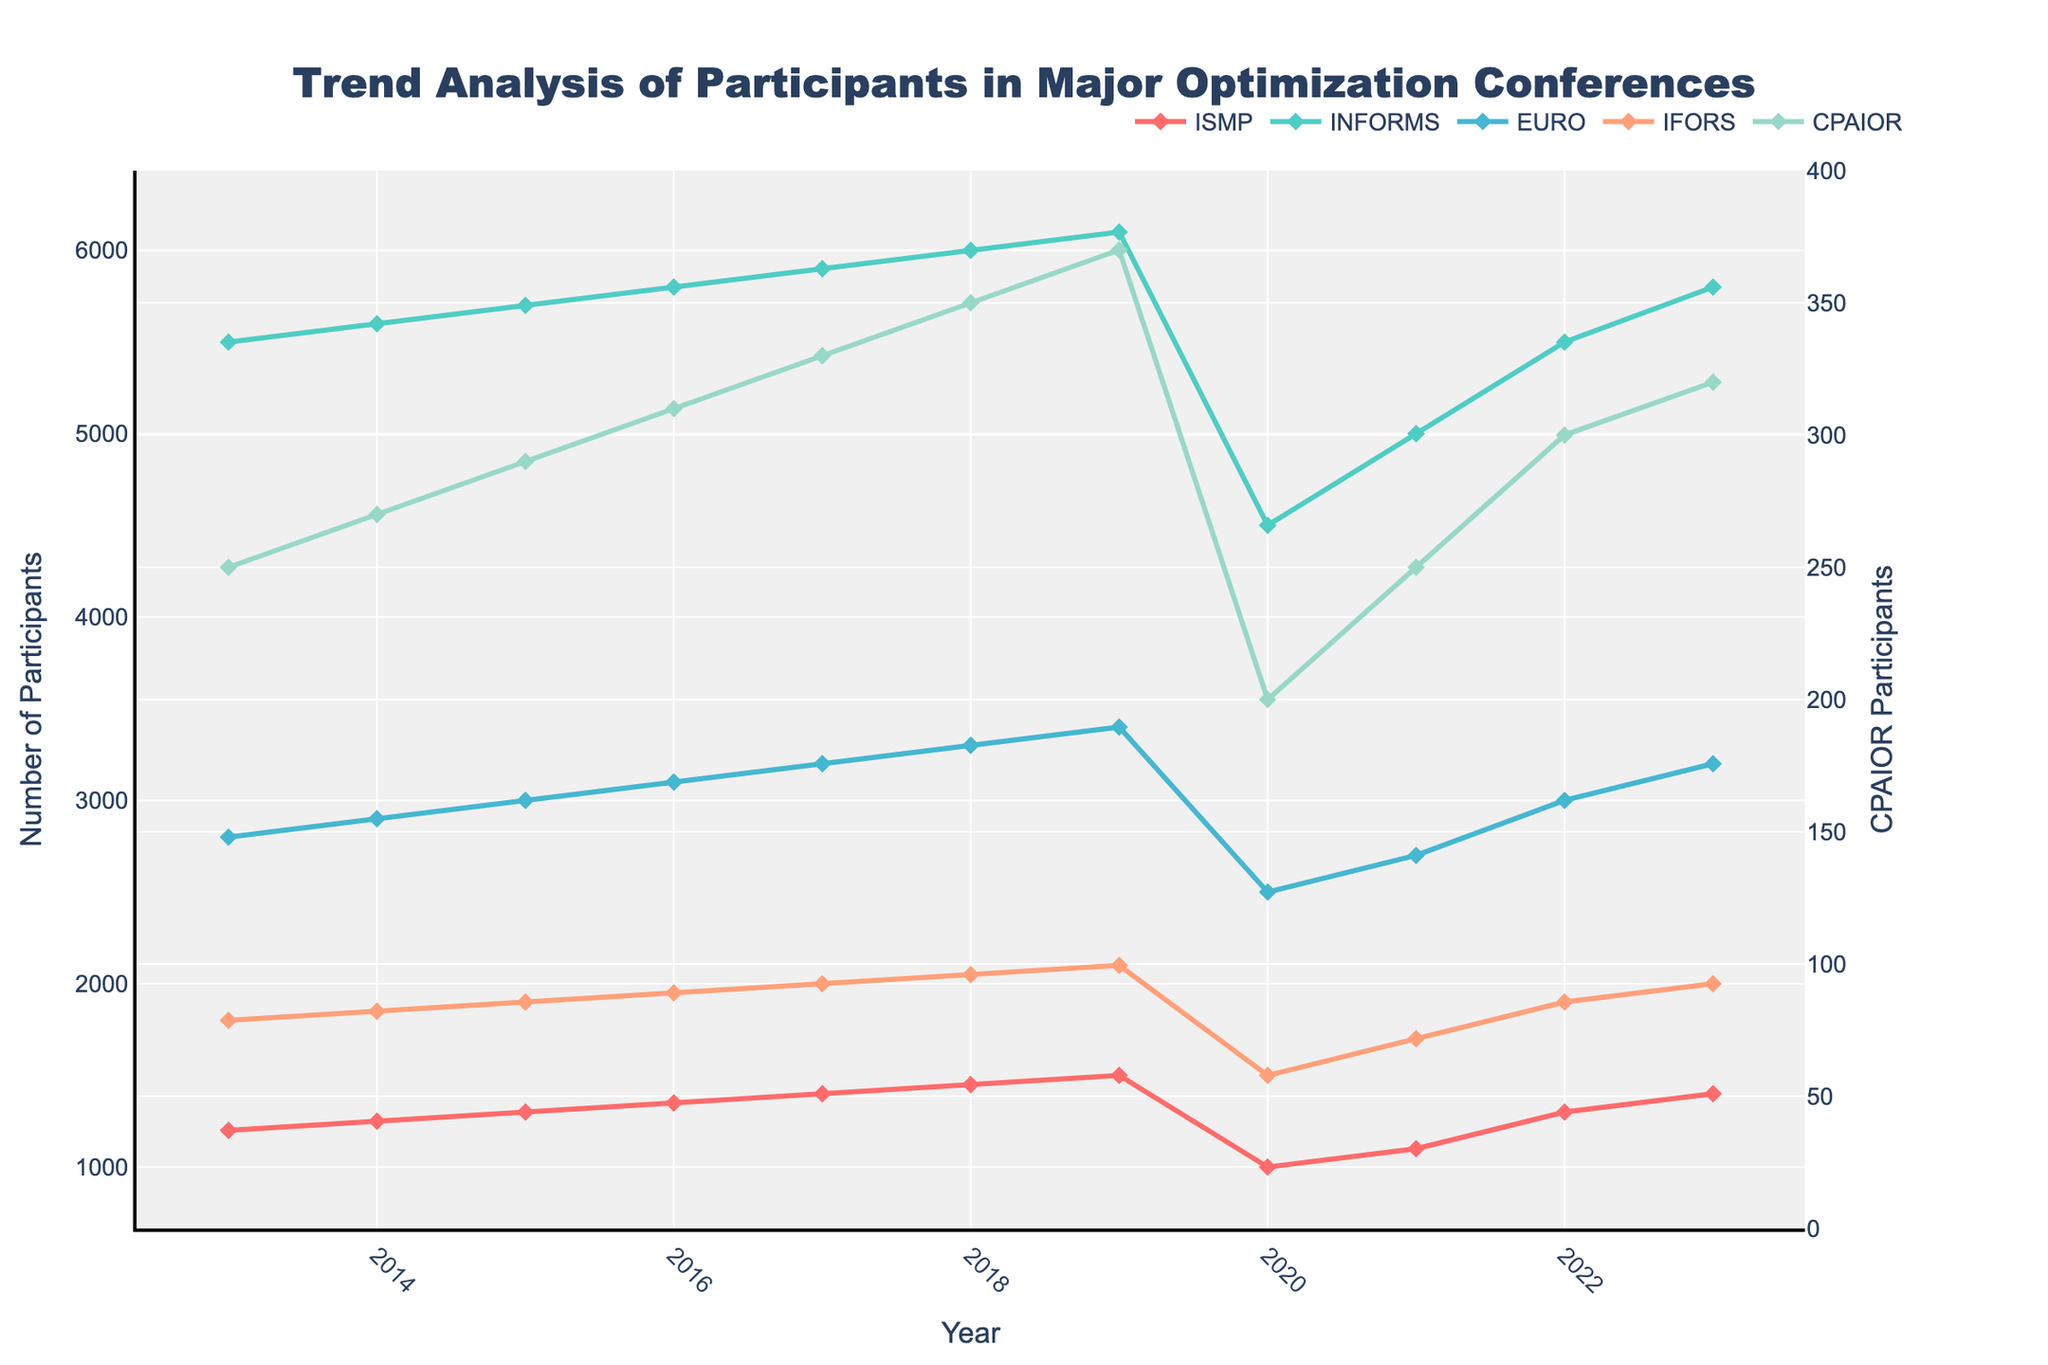What is the trend of participants in the ISMP conference over the years? The number of participants at the ISMP conference has generally increased from 1200 in 2013 to 1500 in 2019. There was a significant drop to 1000 in 2020, but the number showed recovery in subsequent years, reaching 1400 by 2023.
Answer: Increasing, then drop in 2020, recovery afterward What year did the IFORS conference see a decline in participants? In 2020, the number of participants in the IFORS conference dropped from 2100 in 2019 to 1500 in 2020.
Answer: 2020 Compare the growth in participants between the INFORMS and EURO conferences from 2013 to 2023. The INFORMS conference grew from 5500 participants in 2013 to 5800 in 2023, while the EURO conference increased from 2800 to 3200 over the same period. The growth for INFORMS was 300 participants whereas EURO saw an increase of 400 participants.
Answer: INFORMS:  300, EURO: 400 What is the visual difference in the trend lines for INFORMS and CPAIOR? While both the INFORMS and CPAIOR trend lines have upward trends over most of the period, the INFORMS line shows a significant dip in 2020 but quickly recovered. The CPAIOR line is relatively smoother with a smaller fluctuation.
Answer: INFORMS: significant dip and recovery; CPAIOR: smooth, smaller fluctuation If the decline in participants in 2020 didn't occur, estimate the number of participants that should have been in the ISMP conference in 2020, considering the previous trend. The number of ISMP participants was consistently growing by 50 each year from 2013 to 2019. If the trend continued, the expected number in 2020 would be 1550.
Answer: 1550 Which conference had the smallest number of participants in 2023, and how many participants were there? CPAIOR had the smallest number of participants in 2023 with 320 participants.
Answer: CPAIOR, 320 Calculate the average number of participants in the EURO conference from 2013 to 2023. The sum of participants in the EURO conference from 2013 to 2023 is 2800 + 2900 + 3000 + 3100 + 3200 + 3300 + 3400 + 2500 + 2700 + 3000 + 3200 = 32100. The average is 32100 / 11 ≈ 2918.
Answer: 2918 How did participant numbers in the CPAIOR conference change from 2015 to 2018? The number of participants in the CPAIOR conference increased from 290 in 2015 to 350 in 2018, an increase of 60 participants over the 4-year span.
Answer: +60 Which year had the highest number of participants in the INFORMS conference, and what was the number? Both 2022 and 2023 recorded the highest number of participants in the INFORMS conference, with 5800 participants.
Answer: 2022, 2023 with 5800 